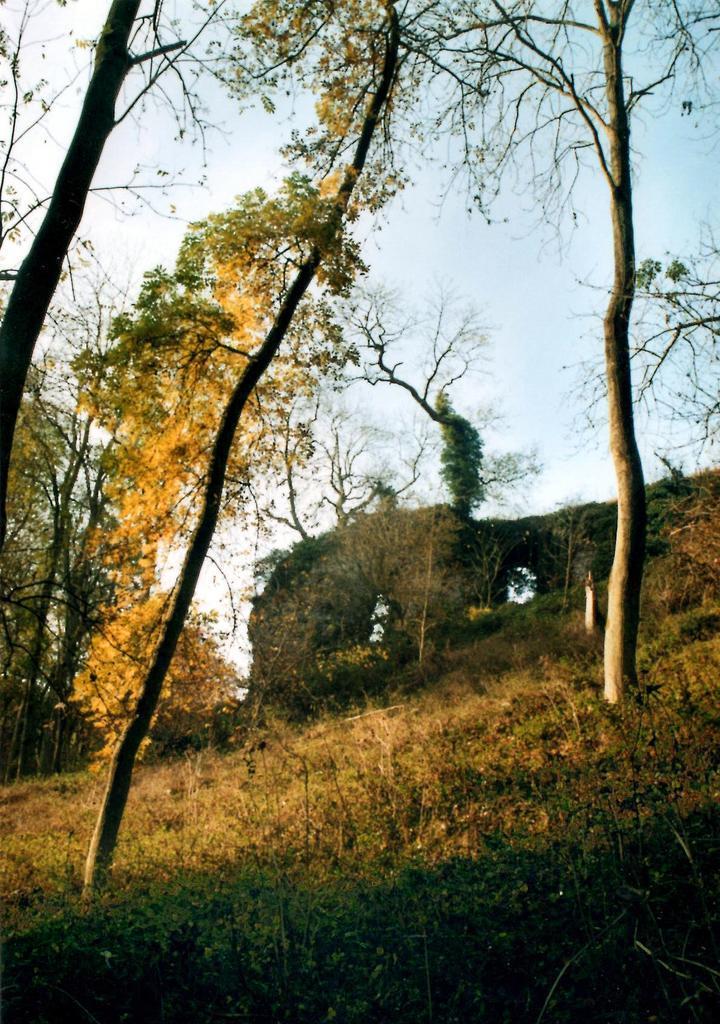Can you describe this image briefly? In this image we can see a building, trees, sky and grass. 